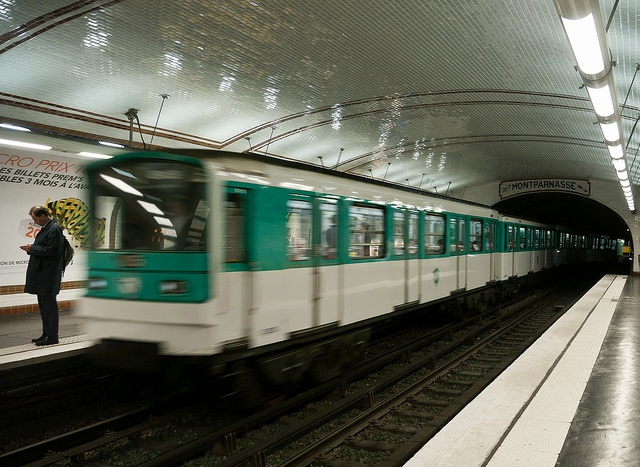Describe the objects in this image and their specific colors. I can see train in blue, black, darkgray, teal, and gray tones and people in blue, black, maroon, and gray tones in this image. 